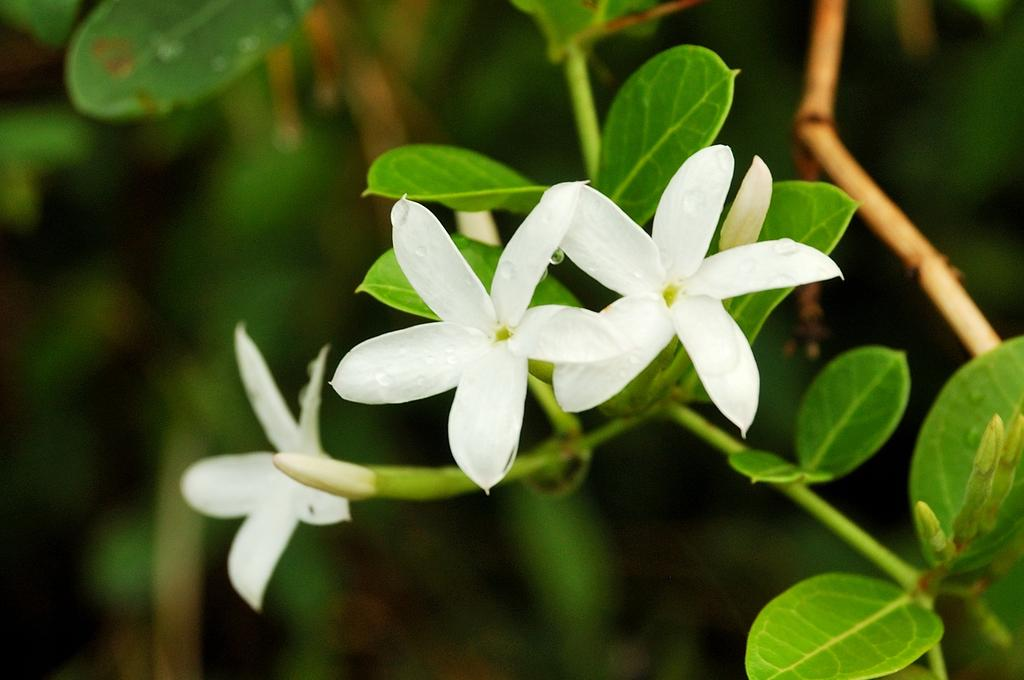What is present on the tree branch in the image? The tree branch has flowers in the image. What color are the flowers on the tree branch? The flowers are white in color. Are there any other parts of the tree branch visible in the image? Yes, there are leaves on the tree branch. What else can be seen in the image besides the tree branch? There are trees visible in the image. How do the friends show respect to each other in the image? There are no friends or any indication of respect in the image; it only features a tree branch with flowers and leaves. 